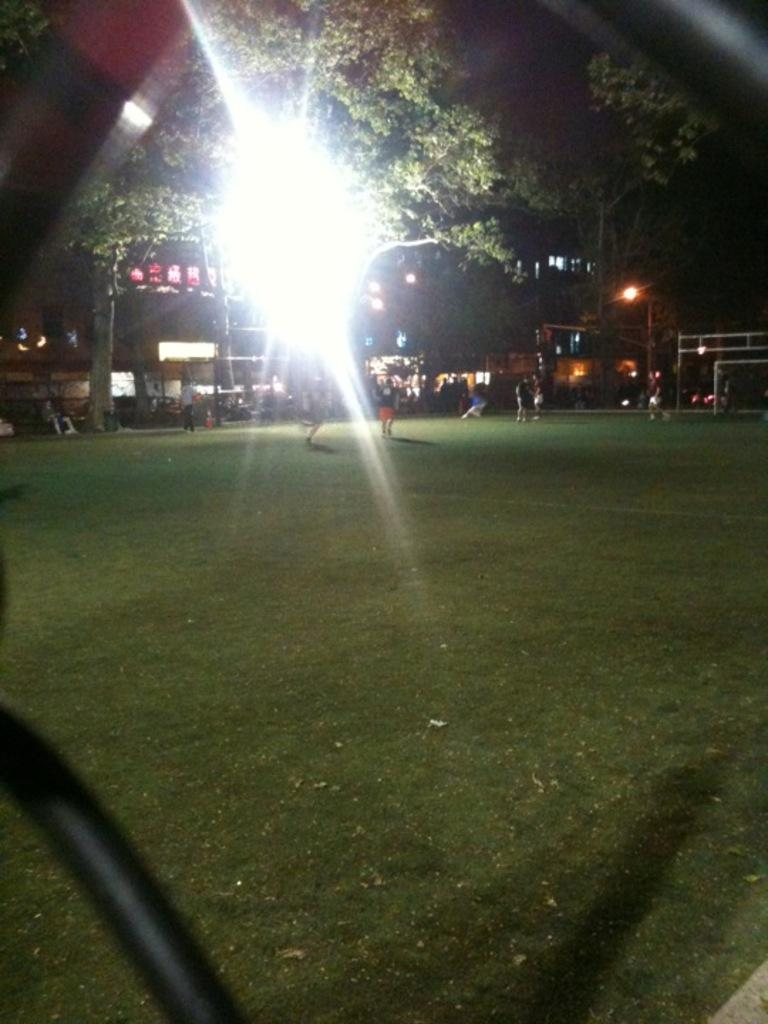What are the people in the image doing? The people in the image are standing on the ground. What is the surface they are standing on? The ground is covered with grass. Can you describe the lighting in the image? Yes, there is lighting in the image. What can be seen in the background of the image? There are trees and buildings visible in the background of the image. What type of thrill can be seen in the image? There is no specific thrill depicted in the image; it simply shows people standing on grassy ground with trees and buildings in the background. 